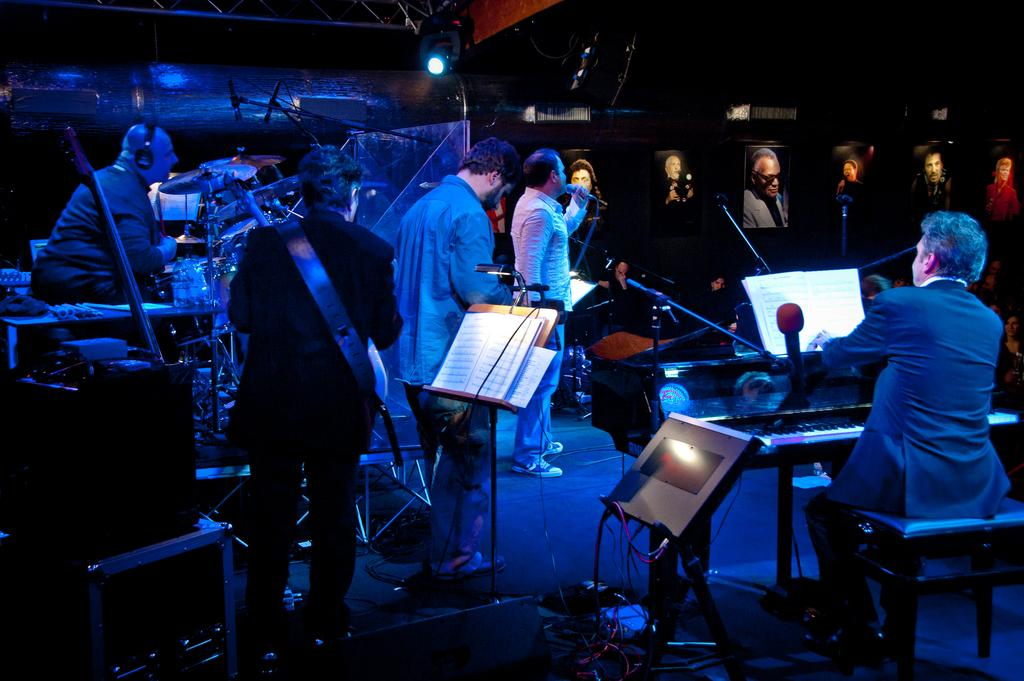What type of event is taking place in the image? The performance in the image is a music concert. What are the people in the image doing? The people are performing in the music concert. What can be seen in the background of the image? There are posters of persons in the background of the image. What type of rice is being served to the audience during the concert? There is no rice present in the image, and it is not mentioned that any food is being served. How many pies are visible on stage during the performance? There are no pies visible in the image; the focus is on the performers and the music concert. 